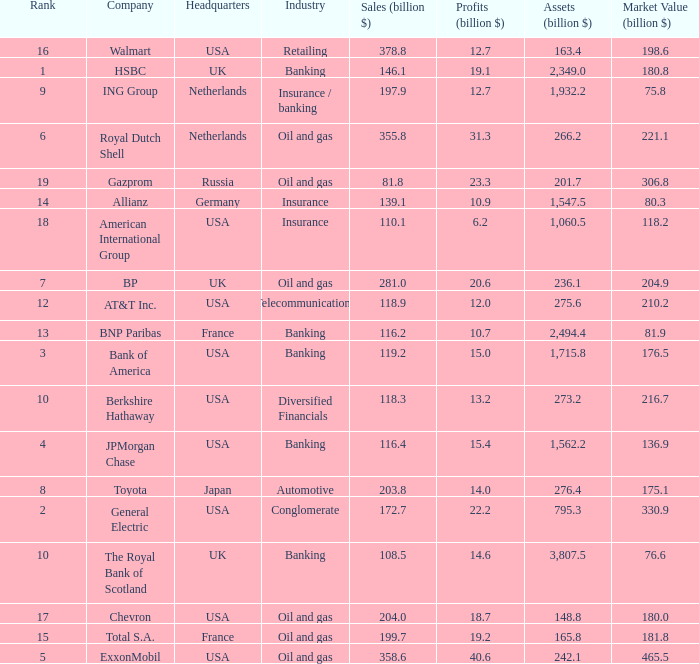What is the highest rank of a company that has 1,715.8 billion in assets?  3.0. 